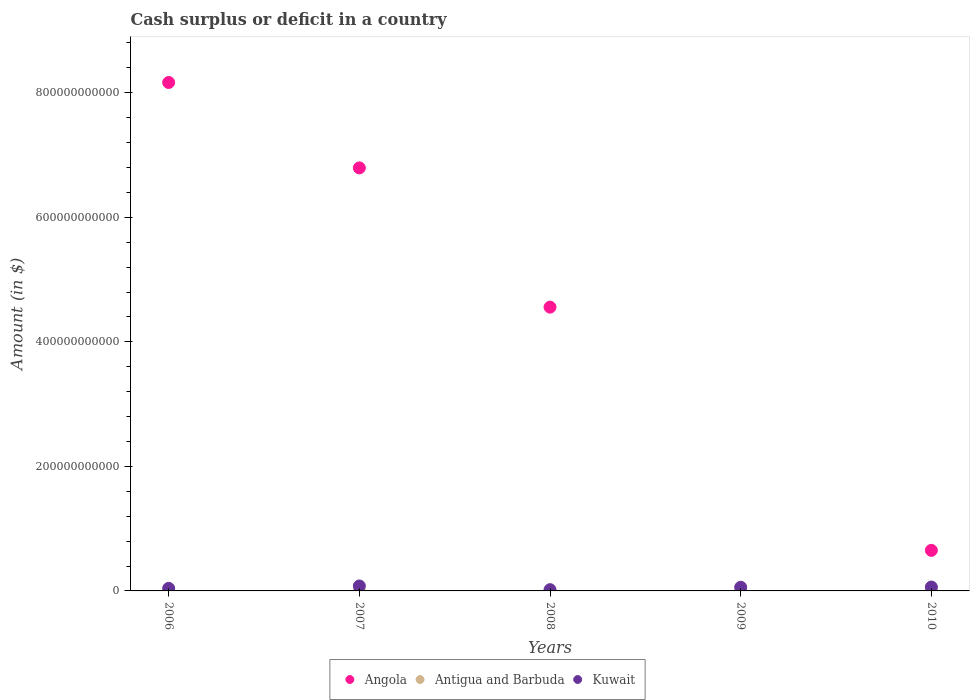How many different coloured dotlines are there?
Give a very brief answer. 2. What is the amount of cash surplus or deficit in Angola in 2008?
Make the answer very short. 4.56e+11. Across all years, what is the maximum amount of cash surplus or deficit in Angola?
Offer a terse response. 8.17e+11. Across all years, what is the minimum amount of cash surplus or deficit in Antigua and Barbuda?
Provide a succinct answer. 0. In which year was the amount of cash surplus or deficit in Kuwait maximum?
Offer a terse response. 2007. What is the total amount of cash surplus or deficit in Kuwait in the graph?
Offer a very short reply. 2.62e+1. What is the difference between the amount of cash surplus or deficit in Angola in 2007 and that in 2008?
Keep it short and to the point. 2.24e+11. What is the difference between the amount of cash surplus or deficit in Kuwait in 2010 and the amount of cash surplus or deficit in Angola in 2007?
Your response must be concise. -6.73e+11. What is the average amount of cash surplus or deficit in Kuwait per year?
Your answer should be very brief. 5.24e+09. What is the ratio of the amount of cash surplus or deficit in Angola in 2006 to that in 2010?
Ensure brevity in your answer.  12.53. What is the difference between the highest and the second highest amount of cash surplus or deficit in Angola?
Ensure brevity in your answer.  1.37e+11. What is the difference between the highest and the lowest amount of cash surplus or deficit in Angola?
Ensure brevity in your answer.  8.17e+11. Is the sum of the amount of cash surplus or deficit in Angola in 2007 and 2008 greater than the maximum amount of cash surplus or deficit in Antigua and Barbuda across all years?
Provide a succinct answer. Yes. Is it the case that in every year, the sum of the amount of cash surplus or deficit in Angola and amount of cash surplus or deficit in Antigua and Barbuda  is greater than the amount of cash surplus or deficit in Kuwait?
Give a very brief answer. No. Does the amount of cash surplus or deficit in Antigua and Barbuda monotonically increase over the years?
Ensure brevity in your answer.  No. Is the amount of cash surplus or deficit in Angola strictly less than the amount of cash surplus or deficit in Antigua and Barbuda over the years?
Ensure brevity in your answer.  No. What is the difference between two consecutive major ticks on the Y-axis?
Your response must be concise. 2.00e+11. Does the graph contain any zero values?
Keep it short and to the point. Yes. Does the graph contain grids?
Ensure brevity in your answer.  No. Where does the legend appear in the graph?
Keep it short and to the point. Bottom center. How many legend labels are there?
Ensure brevity in your answer.  3. How are the legend labels stacked?
Your answer should be compact. Horizontal. What is the title of the graph?
Your answer should be compact. Cash surplus or deficit in a country. Does "Greenland" appear as one of the legend labels in the graph?
Provide a succinct answer. No. What is the label or title of the Y-axis?
Offer a terse response. Amount (in $). What is the Amount (in $) of Angola in 2006?
Give a very brief answer. 8.17e+11. What is the Amount (in $) of Antigua and Barbuda in 2006?
Ensure brevity in your answer.  0. What is the Amount (in $) in Kuwait in 2006?
Make the answer very short. 4.11e+09. What is the Amount (in $) of Angola in 2007?
Provide a succinct answer. 6.79e+11. What is the Amount (in $) of Kuwait in 2007?
Provide a short and direct response. 7.96e+09. What is the Amount (in $) in Angola in 2008?
Provide a succinct answer. 4.56e+11. What is the Amount (in $) in Antigua and Barbuda in 2008?
Your response must be concise. 0. What is the Amount (in $) in Kuwait in 2008?
Provide a succinct answer. 2.00e+09. What is the Amount (in $) in Angola in 2009?
Give a very brief answer. 0. What is the Amount (in $) in Kuwait in 2009?
Offer a very short reply. 5.88e+09. What is the Amount (in $) of Angola in 2010?
Provide a succinct answer. 6.52e+1. What is the Amount (in $) of Antigua and Barbuda in 2010?
Provide a short and direct response. 0. What is the Amount (in $) of Kuwait in 2010?
Make the answer very short. 6.23e+09. Across all years, what is the maximum Amount (in $) of Angola?
Keep it short and to the point. 8.17e+11. Across all years, what is the maximum Amount (in $) of Kuwait?
Give a very brief answer. 7.96e+09. Across all years, what is the minimum Amount (in $) of Angola?
Offer a very short reply. 0. Across all years, what is the minimum Amount (in $) of Kuwait?
Offer a very short reply. 2.00e+09. What is the total Amount (in $) of Angola in the graph?
Provide a succinct answer. 2.02e+12. What is the total Amount (in $) in Antigua and Barbuda in the graph?
Make the answer very short. 0. What is the total Amount (in $) of Kuwait in the graph?
Make the answer very short. 2.62e+1. What is the difference between the Amount (in $) of Angola in 2006 and that in 2007?
Offer a terse response. 1.37e+11. What is the difference between the Amount (in $) in Kuwait in 2006 and that in 2007?
Offer a very short reply. -3.85e+09. What is the difference between the Amount (in $) in Angola in 2006 and that in 2008?
Your response must be concise. 3.61e+11. What is the difference between the Amount (in $) of Kuwait in 2006 and that in 2008?
Keep it short and to the point. 2.11e+09. What is the difference between the Amount (in $) in Kuwait in 2006 and that in 2009?
Give a very brief answer. -1.77e+09. What is the difference between the Amount (in $) in Angola in 2006 and that in 2010?
Offer a very short reply. 7.51e+11. What is the difference between the Amount (in $) of Kuwait in 2006 and that in 2010?
Provide a short and direct response. -2.12e+09. What is the difference between the Amount (in $) of Angola in 2007 and that in 2008?
Offer a very short reply. 2.24e+11. What is the difference between the Amount (in $) of Kuwait in 2007 and that in 2008?
Offer a terse response. 5.96e+09. What is the difference between the Amount (in $) in Kuwait in 2007 and that in 2009?
Your answer should be very brief. 2.08e+09. What is the difference between the Amount (in $) of Angola in 2007 and that in 2010?
Keep it short and to the point. 6.14e+11. What is the difference between the Amount (in $) of Kuwait in 2007 and that in 2010?
Ensure brevity in your answer.  1.73e+09. What is the difference between the Amount (in $) of Kuwait in 2008 and that in 2009?
Ensure brevity in your answer.  -3.88e+09. What is the difference between the Amount (in $) of Angola in 2008 and that in 2010?
Your response must be concise. 3.91e+11. What is the difference between the Amount (in $) of Kuwait in 2008 and that in 2010?
Keep it short and to the point. -4.22e+09. What is the difference between the Amount (in $) in Kuwait in 2009 and that in 2010?
Your answer should be very brief. -3.47e+08. What is the difference between the Amount (in $) in Angola in 2006 and the Amount (in $) in Kuwait in 2007?
Your response must be concise. 8.09e+11. What is the difference between the Amount (in $) in Angola in 2006 and the Amount (in $) in Kuwait in 2008?
Offer a terse response. 8.15e+11. What is the difference between the Amount (in $) in Angola in 2006 and the Amount (in $) in Kuwait in 2009?
Provide a succinct answer. 8.11e+11. What is the difference between the Amount (in $) of Angola in 2006 and the Amount (in $) of Kuwait in 2010?
Your answer should be very brief. 8.10e+11. What is the difference between the Amount (in $) in Angola in 2007 and the Amount (in $) in Kuwait in 2008?
Give a very brief answer. 6.77e+11. What is the difference between the Amount (in $) in Angola in 2007 and the Amount (in $) in Kuwait in 2009?
Offer a terse response. 6.74e+11. What is the difference between the Amount (in $) of Angola in 2007 and the Amount (in $) of Kuwait in 2010?
Your answer should be very brief. 6.73e+11. What is the difference between the Amount (in $) of Angola in 2008 and the Amount (in $) of Kuwait in 2009?
Offer a very short reply. 4.50e+11. What is the difference between the Amount (in $) of Angola in 2008 and the Amount (in $) of Kuwait in 2010?
Ensure brevity in your answer.  4.50e+11. What is the average Amount (in $) of Angola per year?
Keep it short and to the point. 4.03e+11. What is the average Amount (in $) in Antigua and Barbuda per year?
Give a very brief answer. 0. What is the average Amount (in $) in Kuwait per year?
Provide a succinct answer. 5.24e+09. In the year 2006, what is the difference between the Amount (in $) of Angola and Amount (in $) of Kuwait?
Offer a terse response. 8.12e+11. In the year 2007, what is the difference between the Amount (in $) in Angola and Amount (in $) in Kuwait?
Ensure brevity in your answer.  6.71e+11. In the year 2008, what is the difference between the Amount (in $) in Angola and Amount (in $) in Kuwait?
Your answer should be compact. 4.54e+11. In the year 2010, what is the difference between the Amount (in $) of Angola and Amount (in $) of Kuwait?
Provide a succinct answer. 5.89e+1. What is the ratio of the Amount (in $) of Angola in 2006 to that in 2007?
Your answer should be very brief. 1.2. What is the ratio of the Amount (in $) of Kuwait in 2006 to that in 2007?
Ensure brevity in your answer.  0.52. What is the ratio of the Amount (in $) of Angola in 2006 to that in 2008?
Your answer should be very brief. 1.79. What is the ratio of the Amount (in $) in Kuwait in 2006 to that in 2008?
Ensure brevity in your answer.  2.05. What is the ratio of the Amount (in $) of Kuwait in 2006 to that in 2009?
Your response must be concise. 0.7. What is the ratio of the Amount (in $) in Angola in 2006 to that in 2010?
Ensure brevity in your answer.  12.53. What is the ratio of the Amount (in $) of Kuwait in 2006 to that in 2010?
Provide a short and direct response. 0.66. What is the ratio of the Amount (in $) of Angola in 2007 to that in 2008?
Provide a succinct answer. 1.49. What is the ratio of the Amount (in $) of Kuwait in 2007 to that in 2008?
Your response must be concise. 3.97. What is the ratio of the Amount (in $) in Kuwait in 2007 to that in 2009?
Make the answer very short. 1.35. What is the ratio of the Amount (in $) in Angola in 2007 to that in 2010?
Make the answer very short. 10.43. What is the ratio of the Amount (in $) of Kuwait in 2007 to that in 2010?
Offer a terse response. 1.28. What is the ratio of the Amount (in $) in Kuwait in 2008 to that in 2009?
Make the answer very short. 0.34. What is the ratio of the Amount (in $) of Angola in 2008 to that in 2010?
Give a very brief answer. 6.99. What is the ratio of the Amount (in $) of Kuwait in 2008 to that in 2010?
Your response must be concise. 0.32. What is the ratio of the Amount (in $) of Kuwait in 2009 to that in 2010?
Your answer should be compact. 0.94. What is the difference between the highest and the second highest Amount (in $) in Angola?
Give a very brief answer. 1.37e+11. What is the difference between the highest and the second highest Amount (in $) of Kuwait?
Your response must be concise. 1.73e+09. What is the difference between the highest and the lowest Amount (in $) of Angola?
Your response must be concise. 8.17e+11. What is the difference between the highest and the lowest Amount (in $) of Kuwait?
Make the answer very short. 5.96e+09. 